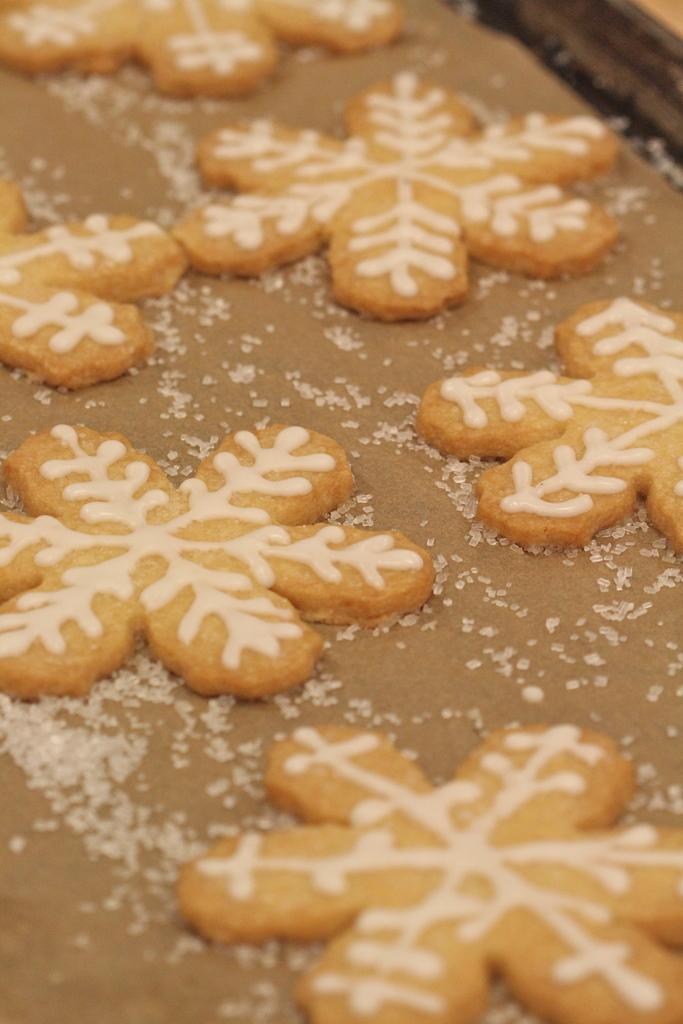In one or two sentences, can you explain what this image depicts? In this picture, we can see some food items on the surface, and we can see some crystal objects on the surface, and we can see some object in the top right corner of the picture. 